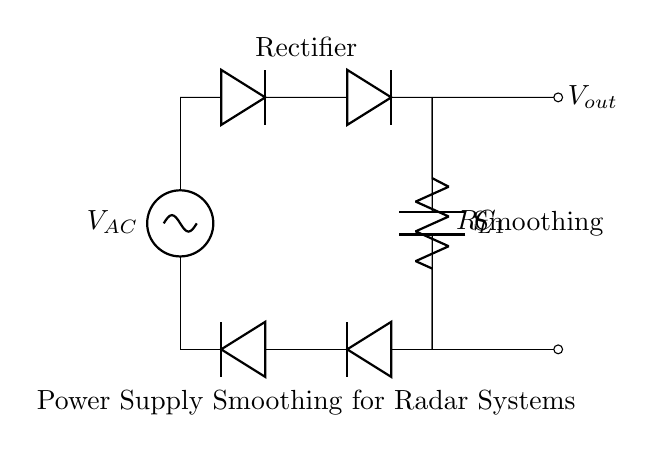What is the type of the voltage source in this circuit? The voltage source is labeled as V_AC, which indicates it is an alternating current (AC) source.
Answer: Alternating current What components form the rectifier in this circuit? The rectifier is made up of two diode components, which are positioned to allow current to pass in one direction only, effectively converting AC to DC.
Answer: Two diodes What is the purpose of the capacitor in this circuit? The capacitor, labeled C_1, is used for smoothing out the voltage by charging when the voltage is high and discharging when the voltage drops, thus reducing voltage ripple.
Answer: Smoothing What is the relationship between the resistor and the capacitor in this circuit? The resistor (R_L) and capacitor (C_1) are connected in parallel and together form an RC circuit that affects the discharge time and the smoothing effect of the circuit.
Answer: Parallel What does the label R_L indicate about the resistor in this circuit? The label R_L suggests that it is a load resistor, which means it is receiving power from the smoother output of the capacitor and is likely to represent the load in the radar system.
Answer: Load resistor How does the smoothing effect of the capacitor impact the output voltage? The smoothing effect of the capacitor reduces voltage ripple, leading to a more stable and consistent output voltage, which is crucial for the performance of radar systems reliant on a steady power supply.
Answer: More stable output voltage What happens to the output voltage if the capacitor value is increased? If the value of the capacitor C_1 is increased, it can store more charge and therefore can sustain the output voltage for a longer time period during discharges, thus further reducing voltage fluctuations.
Answer: Increased stability 